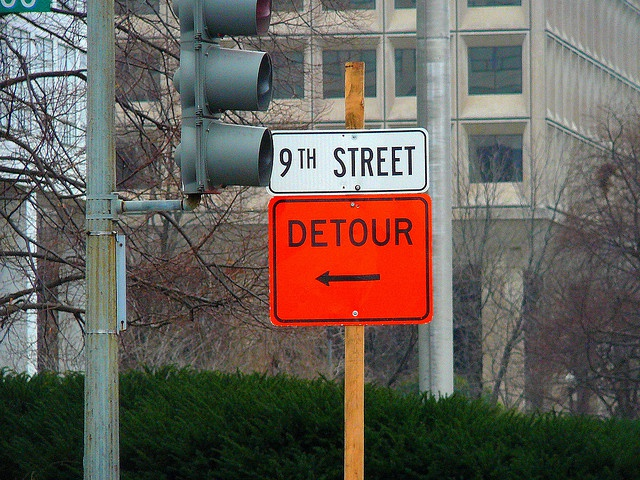Describe the objects in this image and their specific colors. I can see a traffic light in teal, gray, and black tones in this image. 